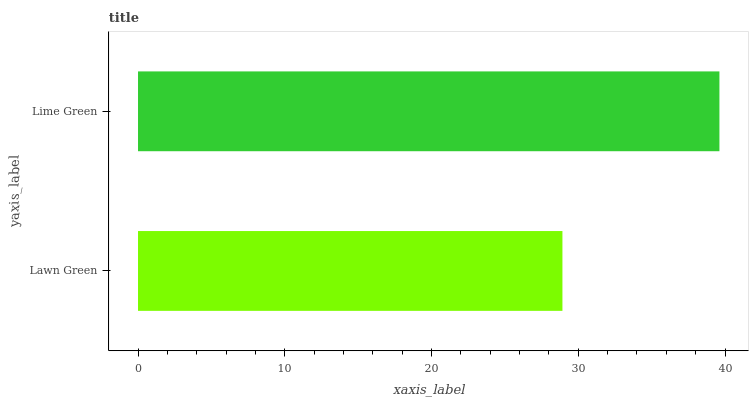Is Lawn Green the minimum?
Answer yes or no. Yes. Is Lime Green the maximum?
Answer yes or no. Yes. Is Lime Green the minimum?
Answer yes or no. No. Is Lime Green greater than Lawn Green?
Answer yes or no. Yes. Is Lawn Green less than Lime Green?
Answer yes or no. Yes. Is Lawn Green greater than Lime Green?
Answer yes or no. No. Is Lime Green less than Lawn Green?
Answer yes or no. No. Is Lime Green the high median?
Answer yes or no. Yes. Is Lawn Green the low median?
Answer yes or no. Yes. Is Lawn Green the high median?
Answer yes or no. No. Is Lime Green the low median?
Answer yes or no. No. 